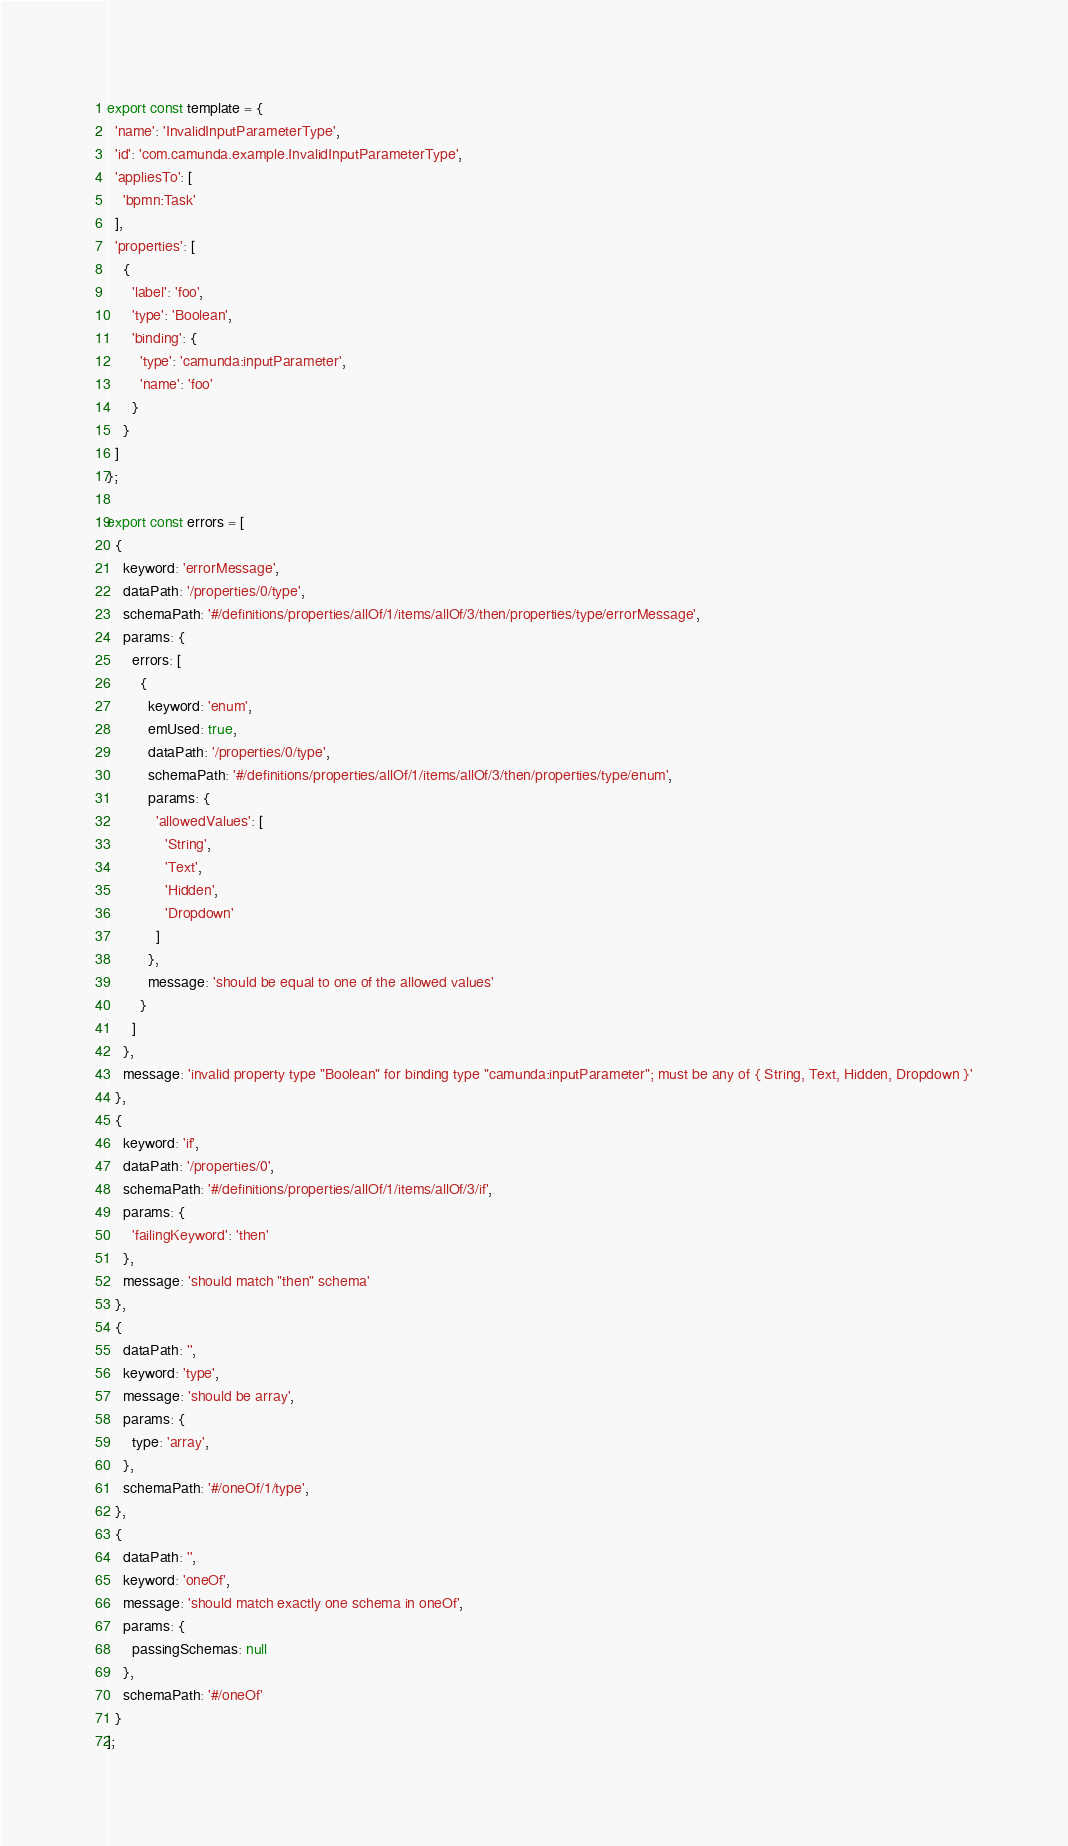Convert code to text. <code><loc_0><loc_0><loc_500><loc_500><_JavaScript_>export const template = {
  'name': 'InvalidInputParameterType',
  'id': 'com.camunda.example.InvalidInputParameterType',
  'appliesTo': [
    'bpmn:Task'
  ],
  'properties': [
    {
      'label': 'foo',
      'type': 'Boolean',
      'binding': {
        'type': 'camunda:inputParameter',
        'name': 'foo'
      }
    }
  ]
};

export const errors = [
  {
    keyword: 'errorMessage',
    dataPath: '/properties/0/type',
    schemaPath: '#/definitions/properties/allOf/1/items/allOf/3/then/properties/type/errorMessage',
    params: {
      errors: [
        {
          keyword: 'enum',
          emUsed: true,
          dataPath: '/properties/0/type',
          schemaPath: '#/definitions/properties/allOf/1/items/allOf/3/then/properties/type/enum',
          params: {
            'allowedValues': [
              'String',
              'Text',
              'Hidden',
              'Dropdown'
            ]
          },
          message: 'should be equal to one of the allowed values'
        }
      ]
    },
    message: 'invalid property type "Boolean" for binding type "camunda:inputParameter"; must be any of { String, Text, Hidden, Dropdown }'
  },
  {
    keyword: 'if',
    dataPath: '/properties/0',
    schemaPath: '#/definitions/properties/allOf/1/items/allOf/3/if',
    params: {
      'failingKeyword': 'then'
    },
    message: 'should match "then" schema'
  },
  {
    dataPath: '',
    keyword: 'type',
    message: 'should be array',
    params: {
      type: 'array',
    },
    schemaPath: '#/oneOf/1/type',
  },
  {
    dataPath: '',
    keyword: 'oneOf',
    message: 'should match exactly one schema in oneOf',
    params: {
      passingSchemas: null
    },
    schemaPath: '#/oneOf'
  }
];
</code> 